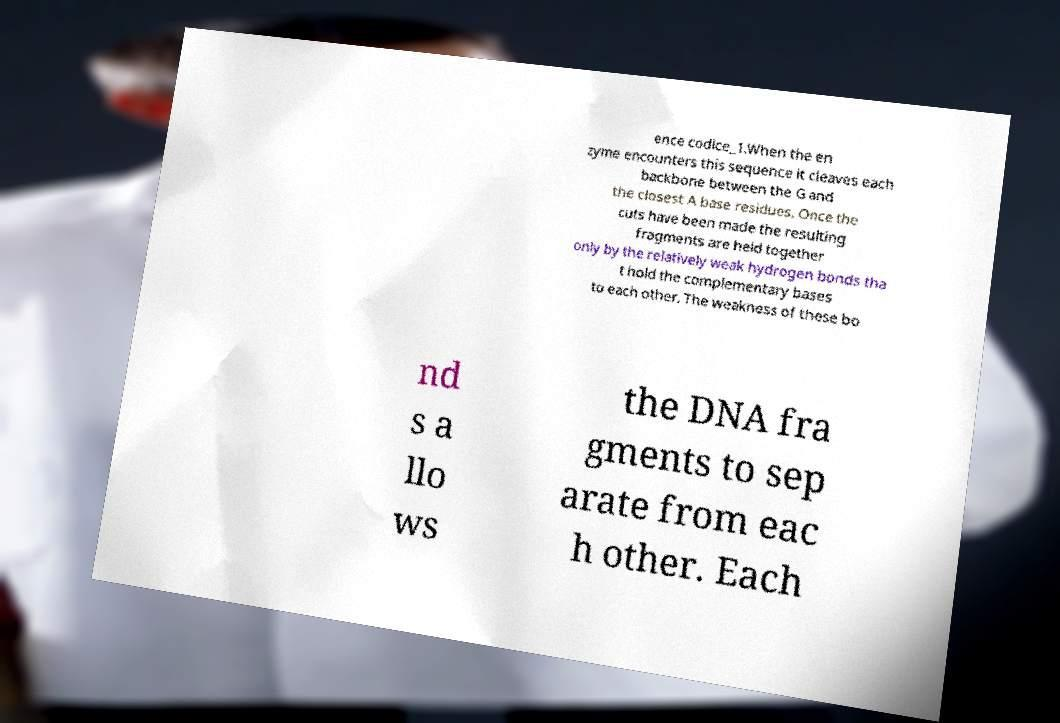There's text embedded in this image that I need extracted. Can you transcribe it verbatim? ence codice_1.When the en zyme encounters this sequence it cleaves each backbone between the G and the closest A base residues. Once the cuts have been made the resulting fragments are held together only by the relatively weak hydrogen bonds tha t hold the complementary bases to each other. The weakness of these bo nd s a llo ws the DNA fra gments to sep arate from eac h other. Each 